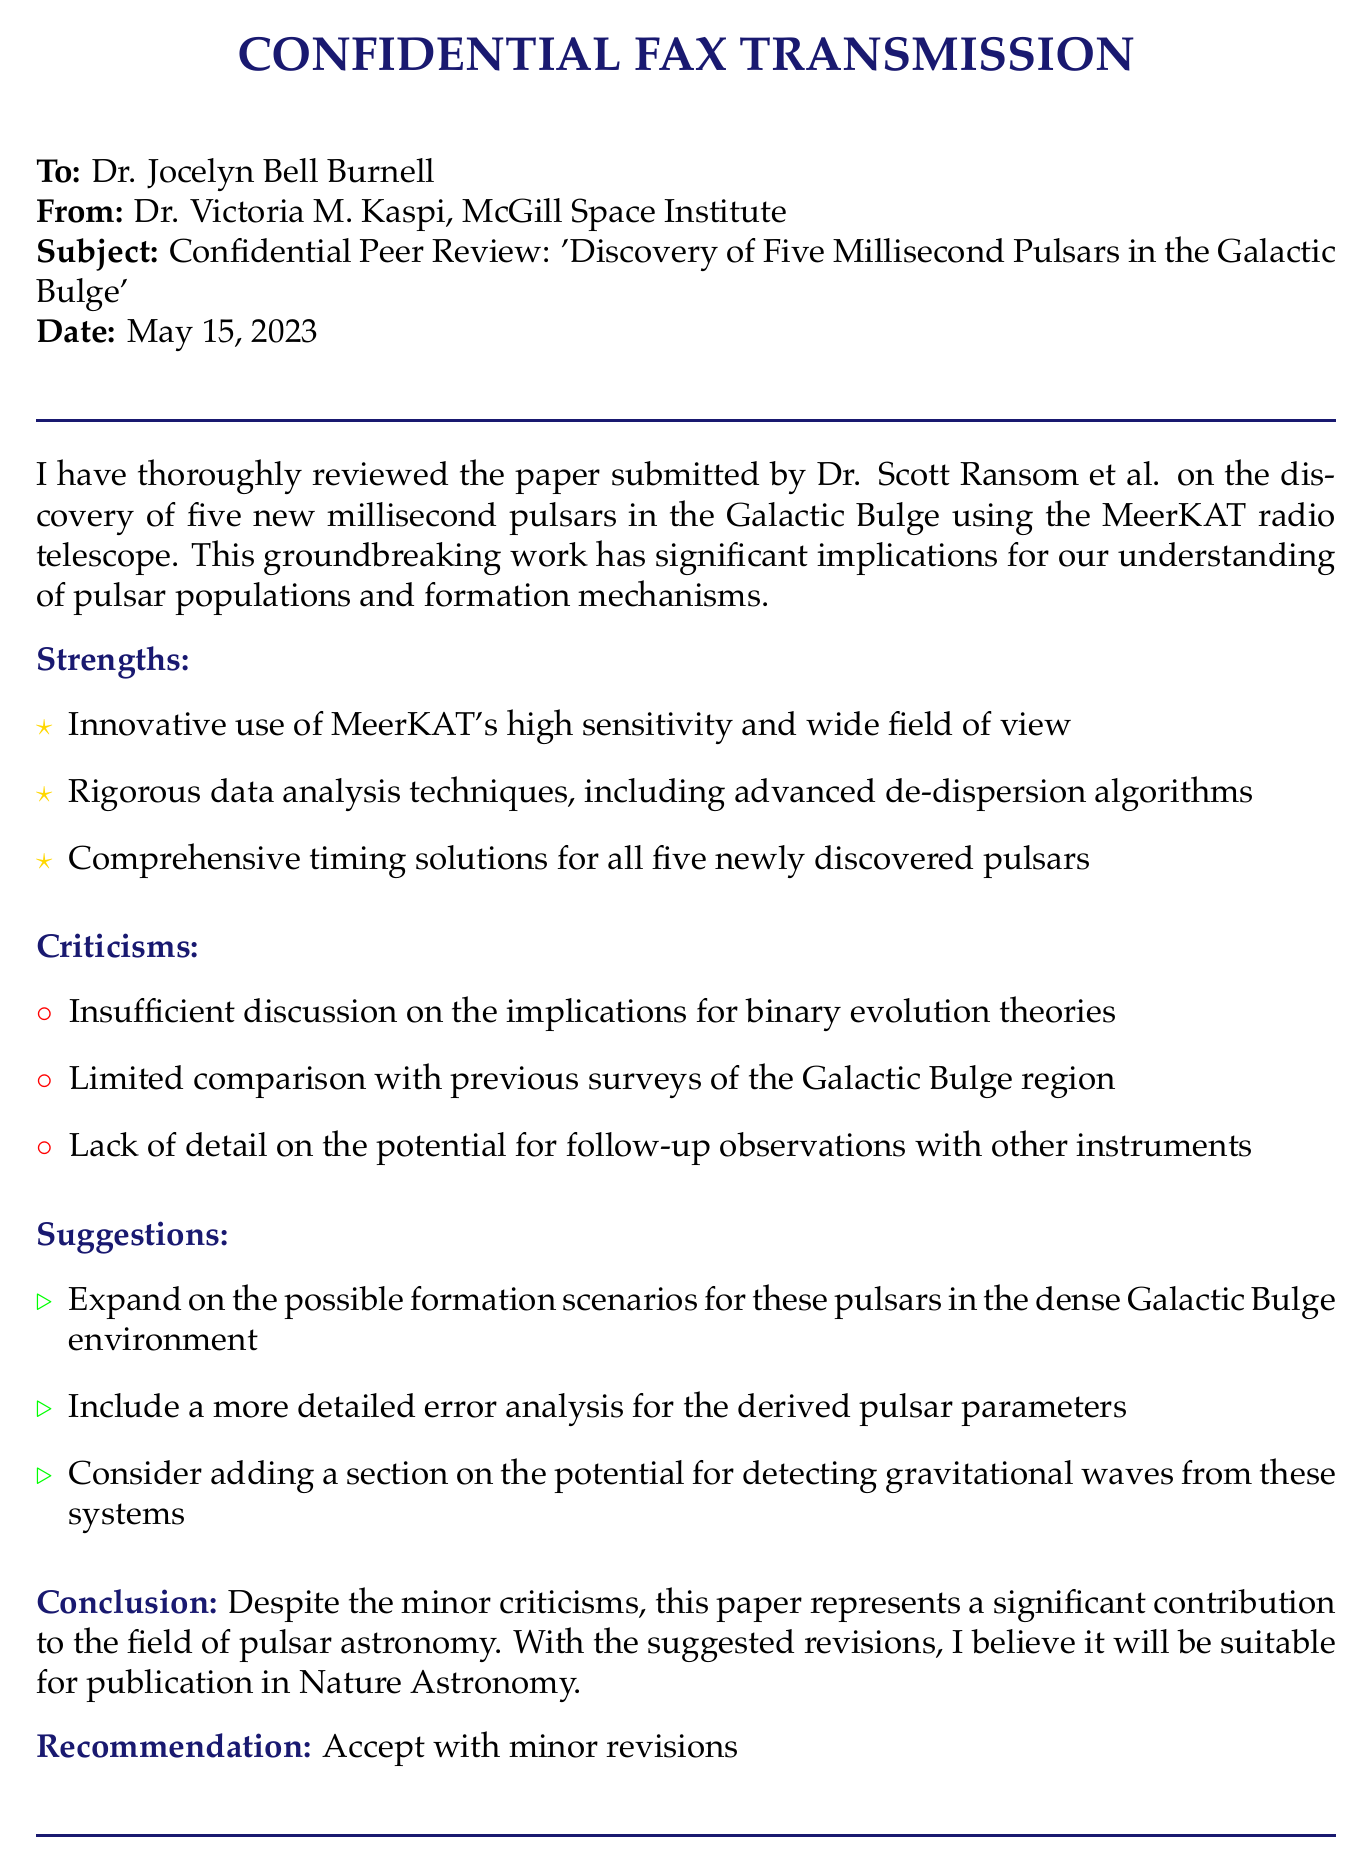What is the subject of the fax? The subject of the fax is mentioned clearly at the beginning of the document, highlighting the content of the peer review.
Answer: Confidential Peer Review: 'Discovery of Five Millisecond Pulsars in the Galactic Bulge' Who authored the paper being reviewed? The authors of the paper are indicated in the first paragraph of the document.
Answer: Dr. Scott Ransom et al What is the date of the fax? The date is specified in the header section of the document.
Answer: May 15, 2023 What was the recommendation given for the paper? The recommendation is stated towards the end of the fax, indicating the reviewer's opinion.
Answer: Accept with minor revisions How many strengths were identified in the review? The number of points listed under strengths can be counted from the document.
Answer: Three What criticism was mentioned regarding the discussion of theories? The specific criticism is stated within the criticisms section of the document.
Answer: Insufficient discussion on the implications for binary evolution theories What suggestion was made regarding gravitational waves? One of the suggestions focuses on the potential for detecting a specific astronomical phenomenon mentioned in the document.
Answer: Add a section on the potential for detecting gravitational waves Which organization is Dr. Victoria M. Kaspi affiliated with? The affiliation is given in the header of the document, indicating the sender's organization.
Answer: McGill Space Institute What tool was used to discover the pulsars? The document mentions the instrument used for the discovery in the opening section.
Answer: MeerKAT radio telescope 